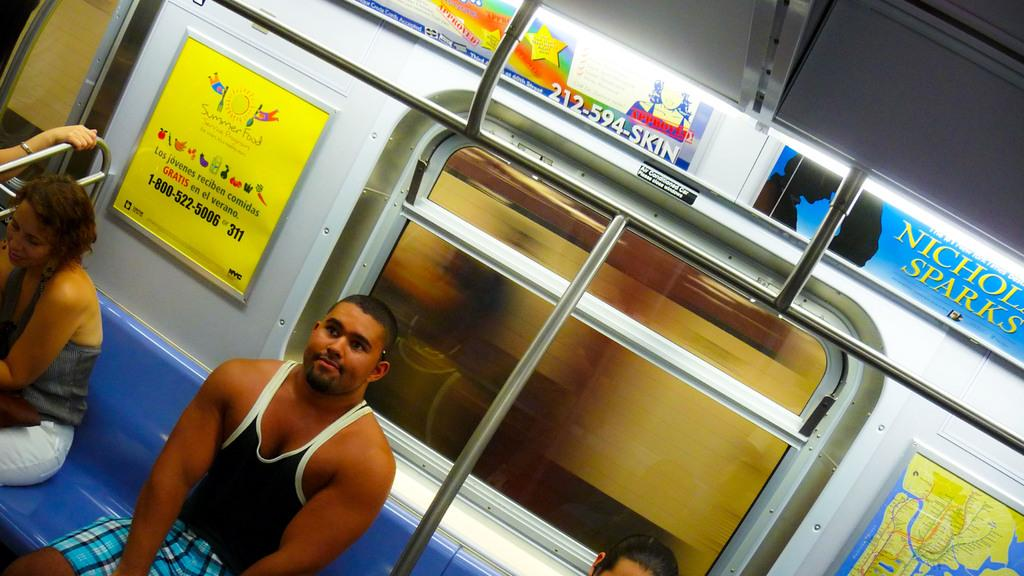<image>
Provide a brief description of the given image. A man sitting on a train with an ad for a Nicholas Sparks book  on the train wall. 